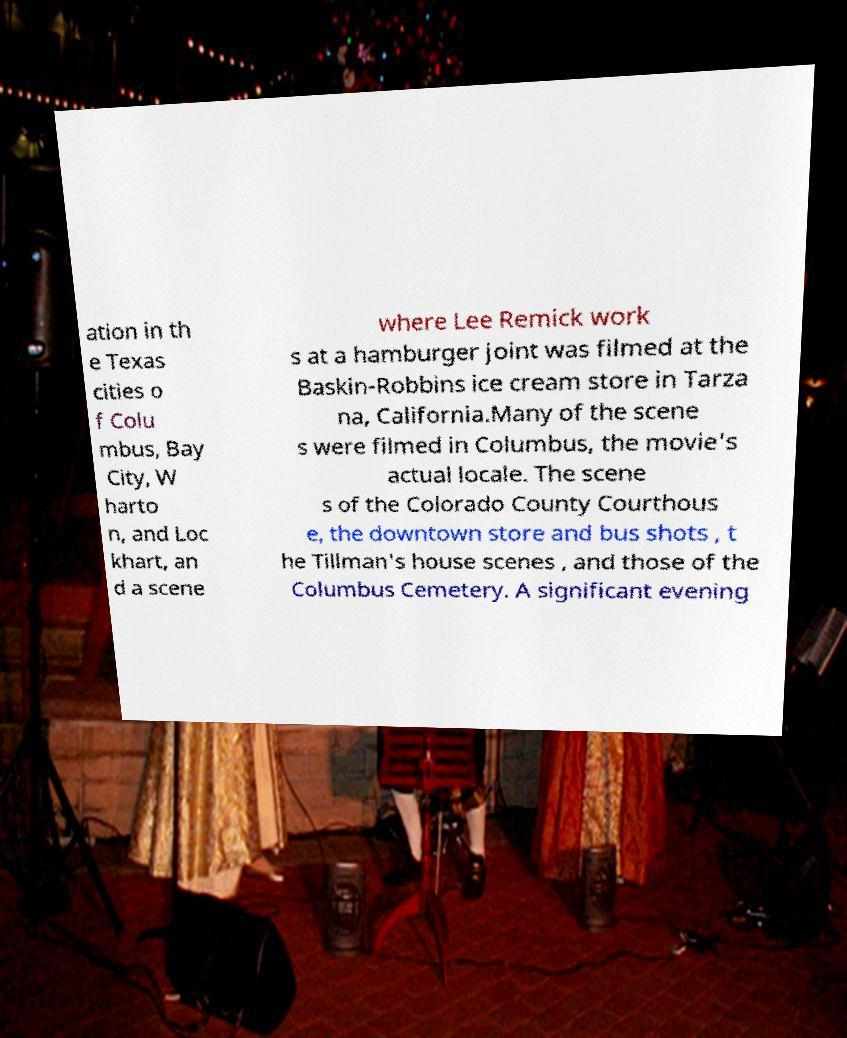Could you extract and type out the text from this image? ation in th e Texas cities o f Colu mbus, Bay City, W harto n, and Loc khart, an d a scene where Lee Remick work s at a hamburger joint was filmed at the Baskin-Robbins ice cream store in Tarza na, California.Many of the scene s were filmed in Columbus, the movie's actual locale. The scene s of the Colorado County Courthous e, the downtown store and bus shots , t he Tillman's house scenes , and those of the Columbus Cemetery. A significant evening 